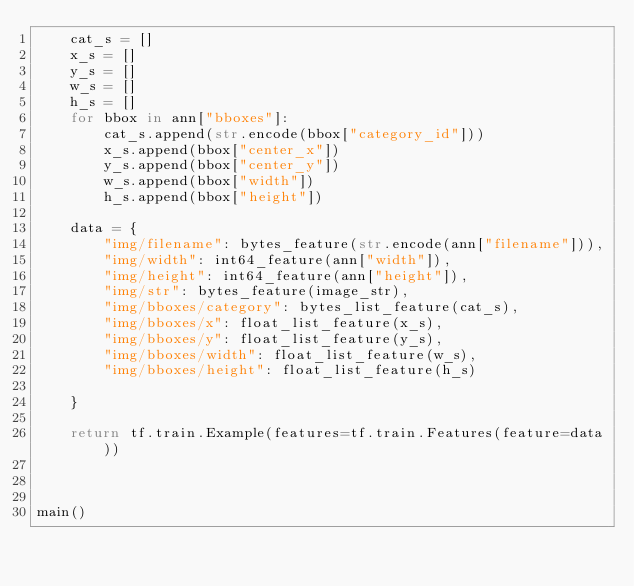<code> <loc_0><loc_0><loc_500><loc_500><_Python_>    cat_s = []
    x_s = []
    y_s = []
    w_s = []
    h_s = []
    for bbox in ann["bboxes"]:
        cat_s.append(str.encode(bbox["category_id"]))
        x_s.append(bbox["center_x"])
        y_s.append(bbox["center_y"])
        w_s.append(bbox["width"])
        h_s.append(bbox["height"])

    data = {
        "img/filename": bytes_feature(str.encode(ann["filename"])),
        "img/width": int64_feature(ann["width"]),
        "img/height": int64_feature(ann["height"]),
        "img/str": bytes_feature(image_str),
        "img/bboxes/category": bytes_list_feature(cat_s),
        "img/bboxes/x": float_list_feature(x_s),
        "img/bboxes/y": float_list_feature(y_s),
        "img/bboxes/width": float_list_feature(w_s),
        "img/bboxes/height": float_list_feature(h_s)

    }

    return tf.train.Example(features=tf.train.Features(feature=data))



main()
</code> 